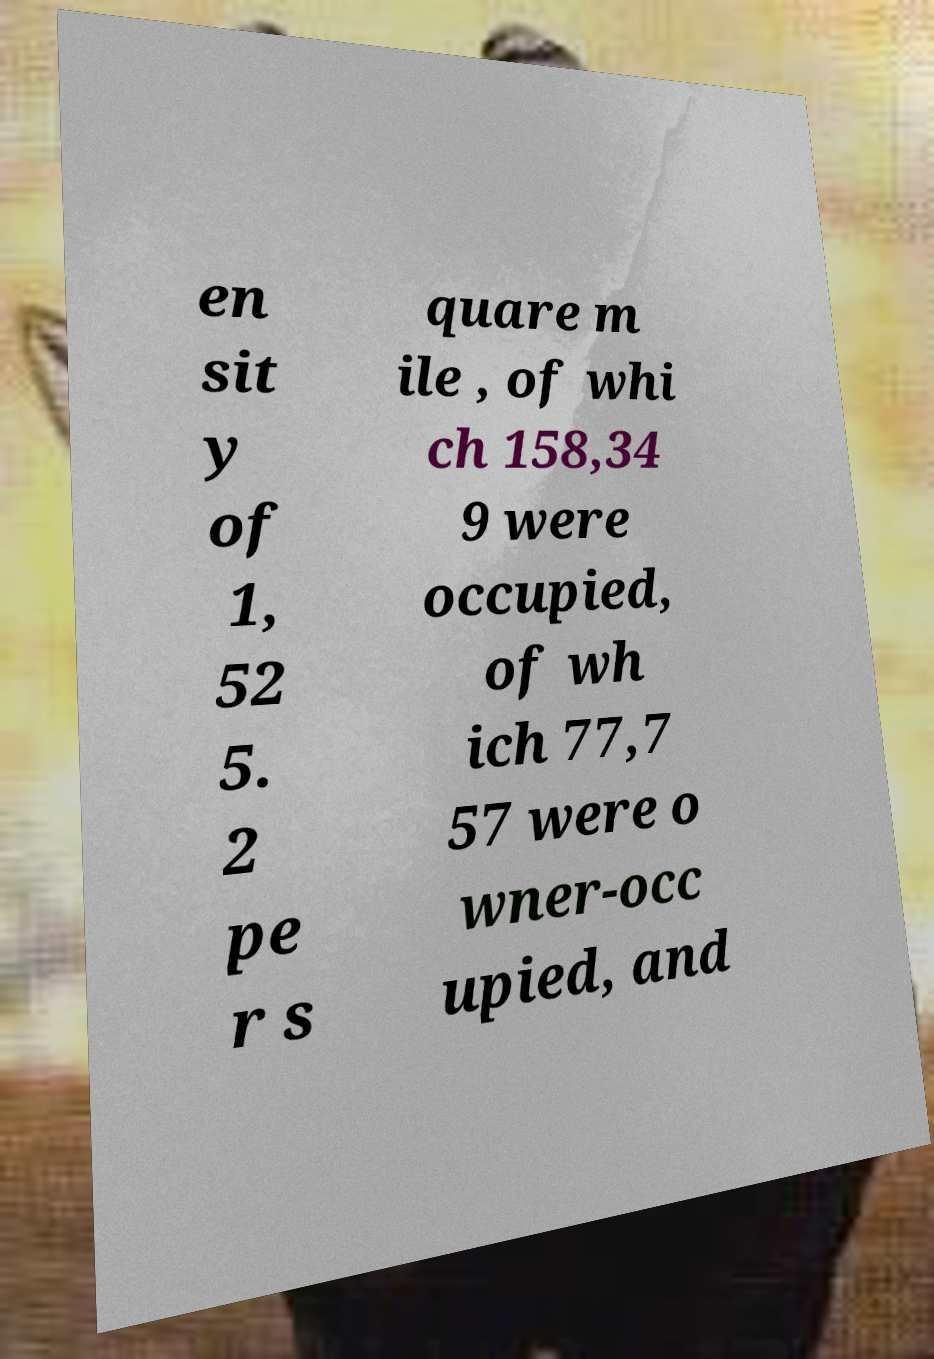Can you read and provide the text displayed in the image?This photo seems to have some interesting text. Can you extract and type it out for me? en sit y of 1, 52 5. 2 pe r s quare m ile , of whi ch 158,34 9 were occupied, of wh ich 77,7 57 were o wner-occ upied, and 